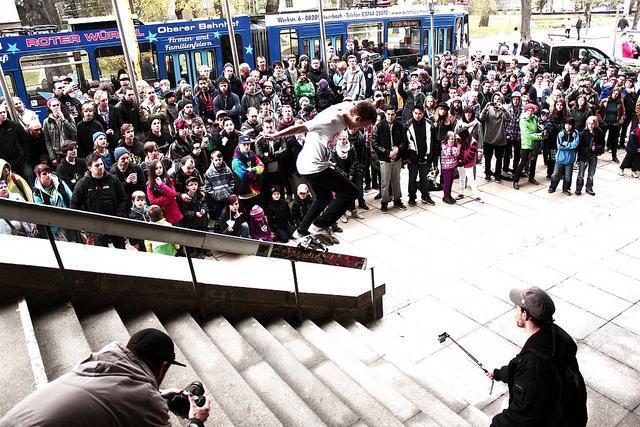How many people are there?
Give a very brief answer. 5. 